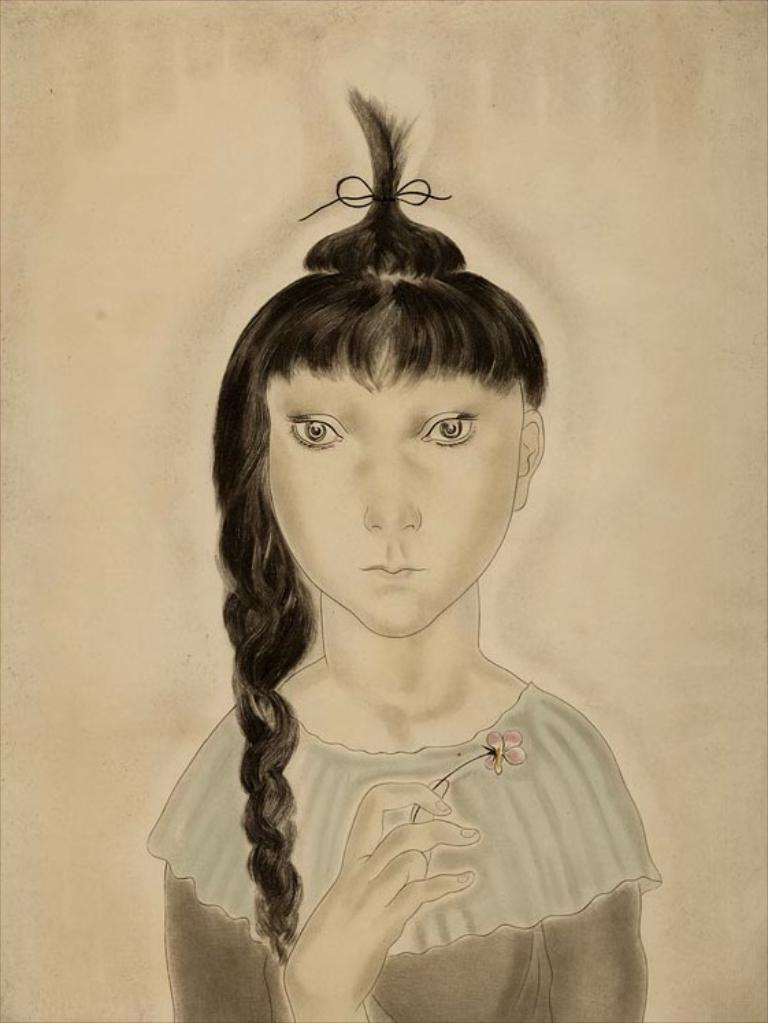What is depicted in the image? There is a drawing of a person in the image. What is the person holding in the drawing? The person is holding a flower in the drawing. What color is the background of the drawing? The background of the drawing is brown in color. What type of hair can be seen on the person in the drawing? There is no hair visible on the person in the drawing, as the drawing only shows the person holding a flower against a brown background. 